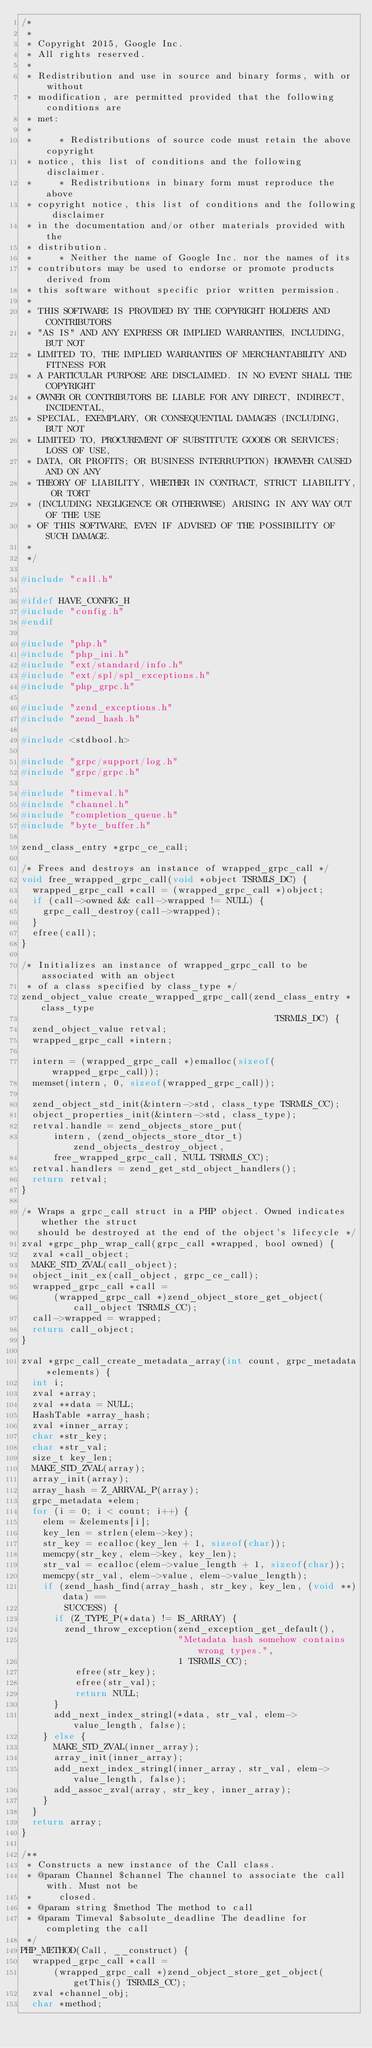Convert code to text. <code><loc_0><loc_0><loc_500><loc_500><_C_>/*
 *
 * Copyright 2015, Google Inc.
 * All rights reserved.
 *
 * Redistribution and use in source and binary forms, with or without
 * modification, are permitted provided that the following conditions are
 * met:
 *
 *     * Redistributions of source code must retain the above copyright
 * notice, this list of conditions and the following disclaimer.
 *     * Redistributions in binary form must reproduce the above
 * copyright notice, this list of conditions and the following disclaimer
 * in the documentation and/or other materials provided with the
 * distribution.
 *     * Neither the name of Google Inc. nor the names of its
 * contributors may be used to endorse or promote products derived from
 * this software without specific prior written permission.
 *
 * THIS SOFTWARE IS PROVIDED BY THE COPYRIGHT HOLDERS AND CONTRIBUTORS
 * "AS IS" AND ANY EXPRESS OR IMPLIED WARRANTIES, INCLUDING, BUT NOT
 * LIMITED TO, THE IMPLIED WARRANTIES OF MERCHANTABILITY AND FITNESS FOR
 * A PARTICULAR PURPOSE ARE DISCLAIMED. IN NO EVENT SHALL THE COPYRIGHT
 * OWNER OR CONTRIBUTORS BE LIABLE FOR ANY DIRECT, INDIRECT, INCIDENTAL,
 * SPECIAL, EXEMPLARY, OR CONSEQUENTIAL DAMAGES (INCLUDING, BUT NOT
 * LIMITED TO, PROCUREMENT OF SUBSTITUTE GOODS OR SERVICES; LOSS OF USE,
 * DATA, OR PROFITS; OR BUSINESS INTERRUPTION) HOWEVER CAUSED AND ON ANY
 * THEORY OF LIABILITY, WHETHER IN CONTRACT, STRICT LIABILITY, OR TORT
 * (INCLUDING NEGLIGENCE OR OTHERWISE) ARISING IN ANY WAY OUT OF THE USE
 * OF THIS SOFTWARE, EVEN IF ADVISED OF THE POSSIBILITY OF SUCH DAMAGE.
 *
 */

#include "call.h"

#ifdef HAVE_CONFIG_H
#include "config.h"
#endif

#include "php.h"
#include "php_ini.h"
#include "ext/standard/info.h"
#include "ext/spl/spl_exceptions.h"
#include "php_grpc.h"

#include "zend_exceptions.h"
#include "zend_hash.h"

#include <stdbool.h>

#include "grpc/support/log.h"
#include "grpc/grpc.h"

#include "timeval.h"
#include "channel.h"
#include "completion_queue.h"
#include "byte_buffer.h"

zend_class_entry *grpc_ce_call;

/* Frees and destroys an instance of wrapped_grpc_call */
void free_wrapped_grpc_call(void *object TSRMLS_DC) {
  wrapped_grpc_call *call = (wrapped_grpc_call *)object;
  if (call->owned && call->wrapped != NULL) {
    grpc_call_destroy(call->wrapped);
  }
  efree(call);
}

/* Initializes an instance of wrapped_grpc_call to be associated with an object
 * of a class specified by class_type */
zend_object_value create_wrapped_grpc_call(zend_class_entry *class_type
                                               TSRMLS_DC) {
  zend_object_value retval;
  wrapped_grpc_call *intern;

  intern = (wrapped_grpc_call *)emalloc(sizeof(wrapped_grpc_call));
  memset(intern, 0, sizeof(wrapped_grpc_call));

  zend_object_std_init(&intern->std, class_type TSRMLS_CC);
  object_properties_init(&intern->std, class_type);
  retval.handle = zend_objects_store_put(
      intern, (zend_objects_store_dtor_t)zend_objects_destroy_object,
      free_wrapped_grpc_call, NULL TSRMLS_CC);
  retval.handlers = zend_get_std_object_handlers();
  return retval;
}

/* Wraps a grpc_call struct in a PHP object. Owned indicates whether the struct
   should be destroyed at the end of the object's lifecycle */
zval *grpc_php_wrap_call(grpc_call *wrapped, bool owned) {
  zval *call_object;
  MAKE_STD_ZVAL(call_object);
  object_init_ex(call_object, grpc_ce_call);
  wrapped_grpc_call *call =
      (wrapped_grpc_call *)zend_object_store_get_object(call_object TSRMLS_CC);
  call->wrapped = wrapped;
  return call_object;
}

zval *grpc_call_create_metadata_array(int count, grpc_metadata *elements) {
  int i;
  zval *array;
  zval **data = NULL;
  HashTable *array_hash;
  zval *inner_array;
  char *str_key;
  char *str_val;
  size_t key_len;
  MAKE_STD_ZVAL(array);
  array_init(array);
  array_hash = Z_ARRVAL_P(array);
  grpc_metadata *elem;
  for (i = 0; i < count; i++) {
    elem = &elements[i];
    key_len = strlen(elem->key);
    str_key = ecalloc(key_len + 1, sizeof(char));
    memcpy(str_key, elem->key, key_len);
    str_val = ecalloc(elem->value_length + 1, sizeof(char));
    memcpy(str_val, elem->value, elem->value_length);
    if (zend_hash_find(array_hash, str_key, key_len, (void **)data) ==
        SUCCESS) {
      if (Z_TYPE_P(*data) != IS_ARRAY) {
        zend_throw_exception(zend_exception_get_default(),
                             "Metadata hash somehow contains wrong types.",
                             1 TSRMLS_CC);
          efree(str_key);
          efree(str_val);
          return NULL;
      }
      add_next_index_stringl(*data, str_val, elem->value_length, false);
    } else {
      MAKE_STD_ZVAL(inner_array);
      array_init(inner_array);
      add_next_index_stringl(inner_array, str_val, elem->value_length, false);
      add_assoc_zval(array, str_key, inner_array);
    }
  }
  return array;
}

/**
 * Constructs a new instance of the Call class.
 * @param Channel $channel The channel to associate the call with. Must not be
 *     closed.
 * @param string $method The method to call
 * @param Timeval $absolute_deadline The deadline for completing the call
 */
PHP_METHOD(Call, __construct) {
  wrapped_grpc_call *call =
      (wrapped_grpc_call *)zend_object_store_get_object(getThis() TSRMLS_CC);
  zval *channel_obj;
  char *method;</code> 